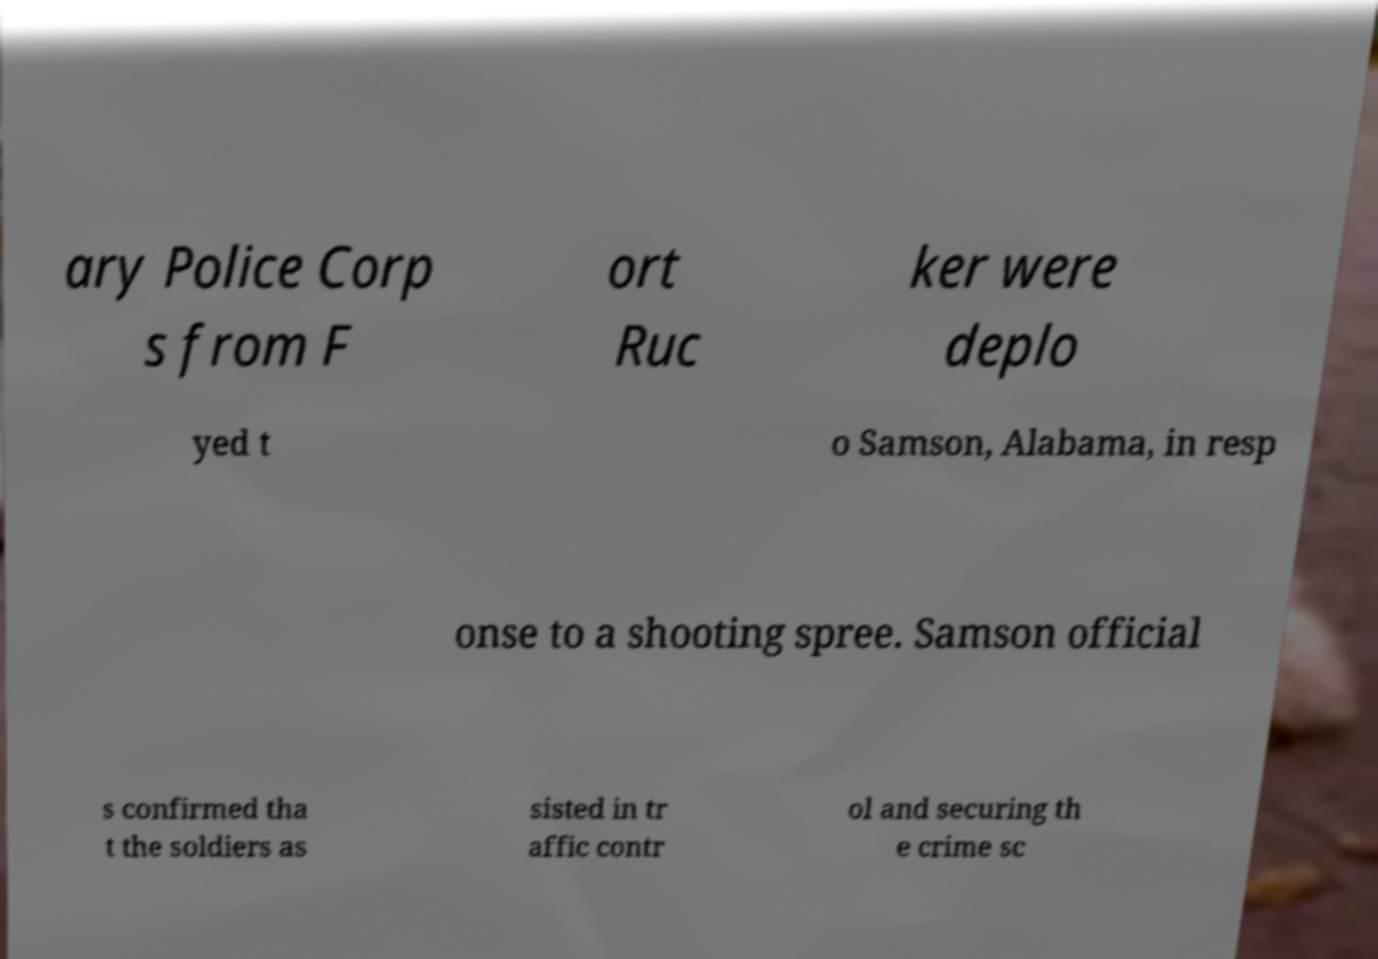Could you extract and type out the text from this image? ary Police Corp s from F ort Ruc ker were deplo yed t o Samson, Alabama, in resp onse to a shooting spree. Samson official s confirmed tha t the soldiers as sisted in tr affic contr ol and securing th e crime sc 